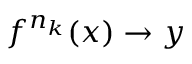<formula> <loc_0><loc_0><loc_500><loc_500>f ^ { n _ { k } } ( x ) \rightarrow y</formula> 